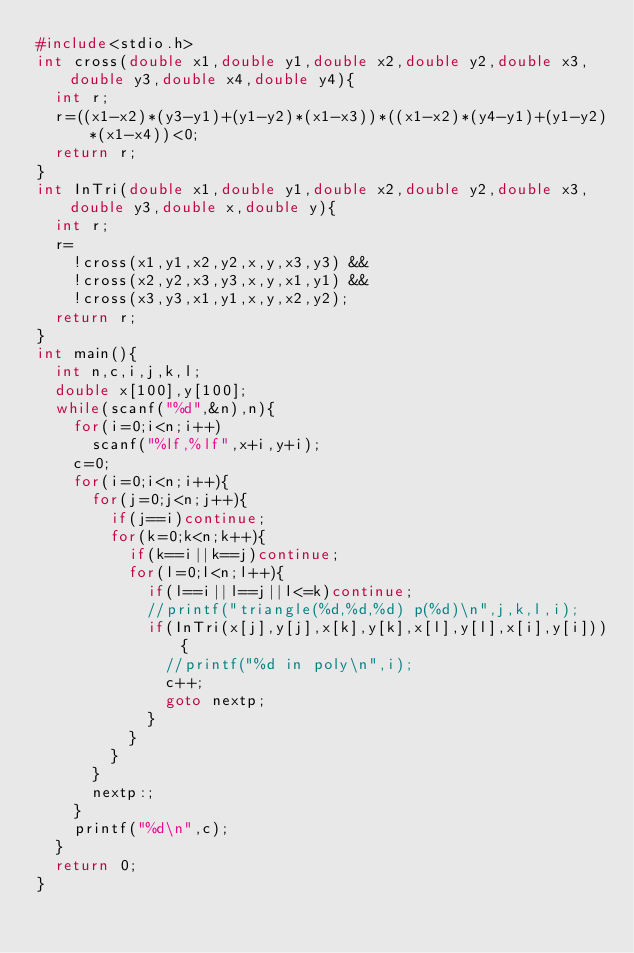Convert code to text. <code><loc_0><loc_0><loc_500><loc_500><_C_>#include<stdio.h>
int cross(double x1,double y1,double x2,double y2,double x3,double y3,double x4,double y4){
	int r;
	r=((x1-x2)*(y3-y1)+(y1-y2)*(x1-x3))*((x1-x2)*(y4-y1)+(y1-y2)*(x1-x4))<0;
	return r;
}
int InTri(double x1,double y1,double x2,double y2,double x3,double y3,double x,double y){
	int r;
	r=
		!cross(x1,y1,x2,y2,x,y,x3,y3) &&
		!cross(x2,y2,x3,y3,x,y,x1,y1) &&
		!cross(x3,y3,x1,y1,x,y,x2,y2);
	return r;
}
int main(){
	int n,c,i,j,k,l;
	double x[100],y[100];
	while(scanf("%d",&n),n){
		for(i=0;i<n;i++)
			scanf("%lf,%lf",x+i,y+i);
		c=0;
		for(i=0;i<n;i++){
			for(j=0;j<n;j++){
				if(j==i)continue;
				for(k=0;k<n;k++){
					if(k==i||k==j)continue;
					for(l=0;l<n;l++){
						if(l==i||l==j||l<=k)continue;
						//printf("triangle(%d,%d,%d) p(%d)\n",j,k,l,i);
						if(InTri(x[j],y[j],x[k],y[k],x[l],y[l],x[i],y[i])){
							//printf("%d in poly\n",i);
							c++;
							goto nextp;
						}
					}
				}
			}
			nextp:;
		}
		printf("%d\n",c);
	}
	return 0;
}</code> 